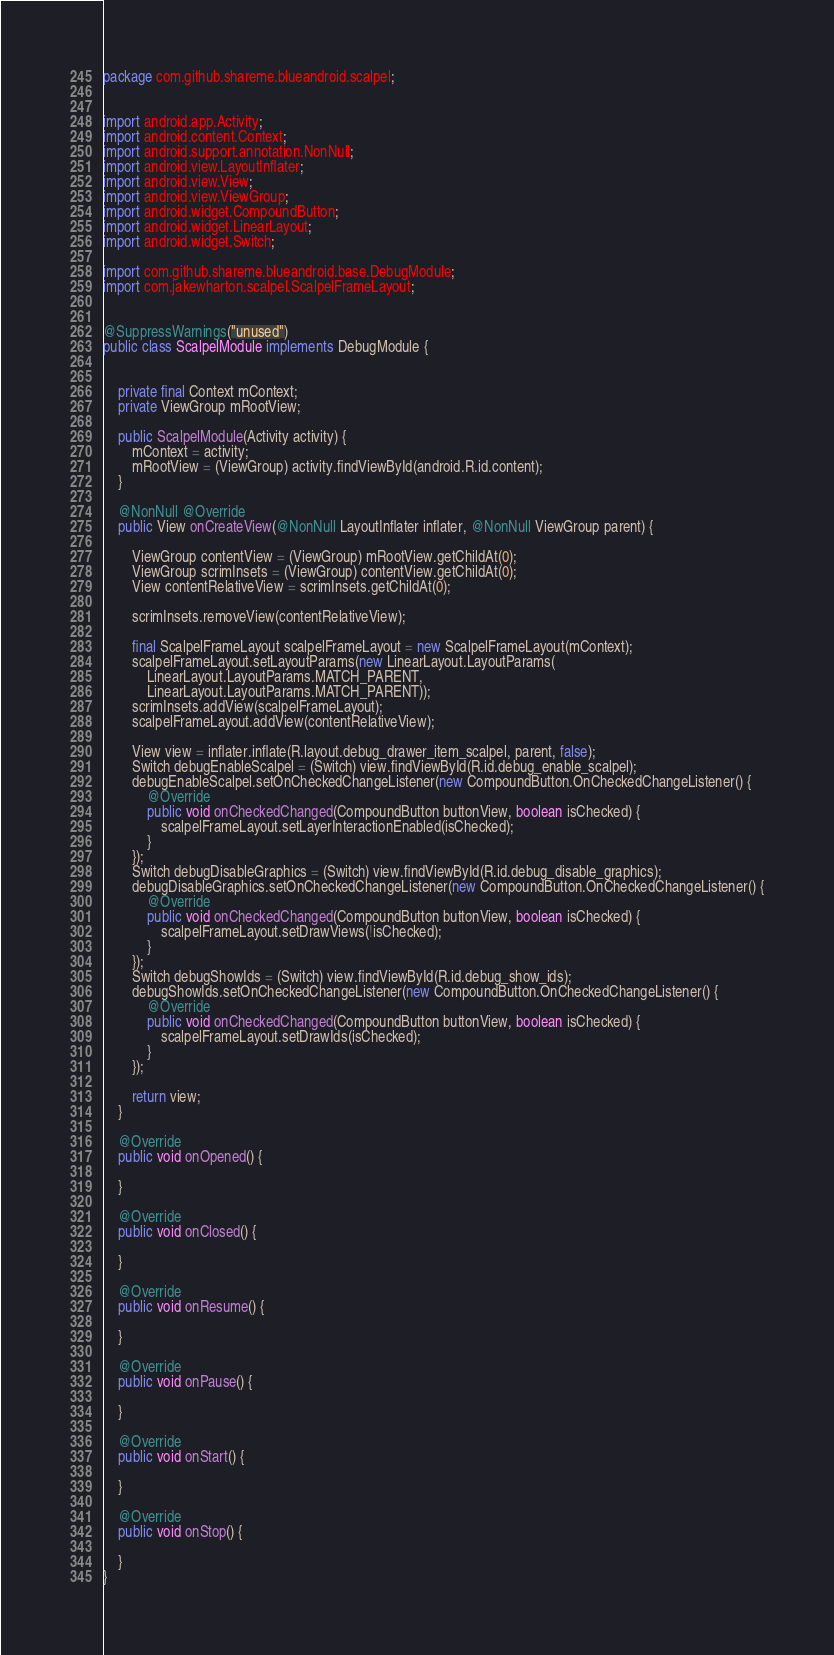<code> <loc_0><loc_0><loc_500><loc_500><_Java_>package com.github.shareme.blueandroid.scalpel;


import android.app.Activity;
import android.content.Context;
import android.support.annotation.NonNull;
import android.view.LayoutInflater;
import android.view.View;
import android.view.ViewGroup;
import android.widget.CompoundButton;
import android.widget.LinearLayout;
import android.widget.Switch;

import com.github.shareme.blueandroid.base.DebugModule;
import com.jakewharton.scalpel.ScalpelFrameLayout;


@SuppressWarnings("unused")
public class ScalpelModule implements DebugModule {


    private final Context mContext;
    private ViewGroup mRootView;

    public ScalpelModule(Activity activity) {
        mContext = activity;
        mRootView = (ViewGroup) activity.findViewById(android.R.id.content);
    }

    @NonNull @Override
    public View onCreateView(@NonNull LayoutInflater inflater, @NonNull ViewGroup parent) {

        ViewGroup contentView = (ViewGroup) mRootView.getChildAt(0);
        ViewGroup scrimInsets = (ViewGroup) contentView.getChildAt(0);
        View contentRelativeView = scrimInsets.getChildAt(0);

        scrimInsets.removeView(contentRelativeView);

        final ScalpelFrameLayout scalpelFrameLayout = new ScalpelFrameLayout(mContext);
        scalpelFrameLayout.setLayoutParams(new LinearLayout.LayoutParams(
            LinearLayout.LayoutParams.MATCH_PARENT,
            LinearLayout.LayoutParams.MATCH_PARENT));
        scrimInsets.addView(scalpelFrameLayout);
        scalpelFrameLayout.addView(contentRelativeView);

        View view = inflater.inflate(R.layout.debug_drawer_item_scalpel, parent, false);
        Switch debugEnableScalpel = (Switch) view.findViewById(R.id.debug_enable_scalpel);
        debugEnableScalpel.setOnCheckedChangeListener(new CompoundButton.OnCheckedChangeListener() {
            @Override
            public void onCheckedChanged(CompoundButton buttonView, boolean isChecked) {
                scalpelFrameLayout.setLayerInteractionEnabled(isChecked);
            }
        });
        Switch debugDisableGraphics = (Switch) view.findViewById(R.id.debug_disable_graphics);
        debugDisableGraphics.setOnCheckedChangeListener(new CompoundButton.OnCheckedChangeListener() {
            @Override
            public void onCheckedChanged(CompoundButton buttonView, boolean isChecked) {
                scalpelFrameLayout.setDrawViews(!isChecked);
            }
        });
        Switch debugShowIds = (Switch) view.findViewById(R.id.debug_show_ids);
        debugShowIds.setOnCheckedChangeListener(new CompoundButton.OnCheckedChangeListener() {
            @Override
            public void onCheckedChanged(CompoundButton buttonView, boolean isChecked) {
                scalpelFrameLayout.setDrawIds(isChecked);
            }
        });

        return view;
    }

    @Override
    public void onOpened() {

    }

    @Override
    public void onClosed() {

    }

    @Override
    public void onResume() {

    }

    @Override
    public void onPause() {

    }

    @Override
    public void onStart() {

    }

    @Override
    public void onStop() {

    }
}
</code> 